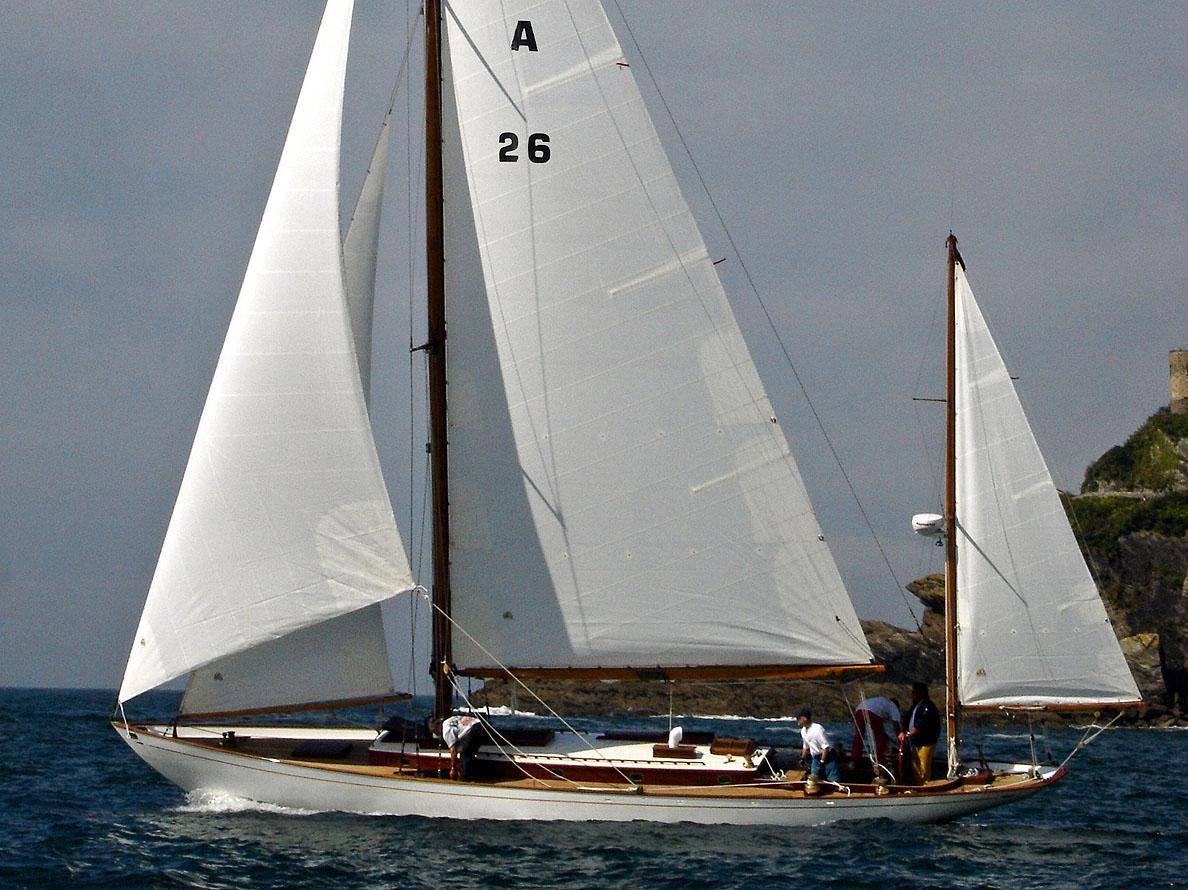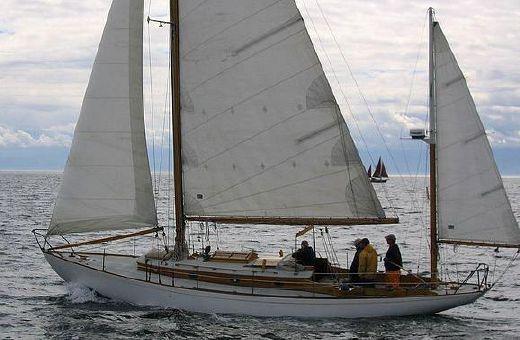The first image is the image on the left, the second image is the image on the right. For the images displayed, is the sentence "The ship in the right image is sailing in front of a land bar" factually correct? Answer yes or no. No. 